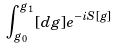Convert formula to latex. <formula><loc_0><loc_0><loc_500><loc_500>\int _ { g _ { 0 } } ^ { g _ { 1 } } [ d { g } ] e ^ { - i S [ { g } ] }</formula> 